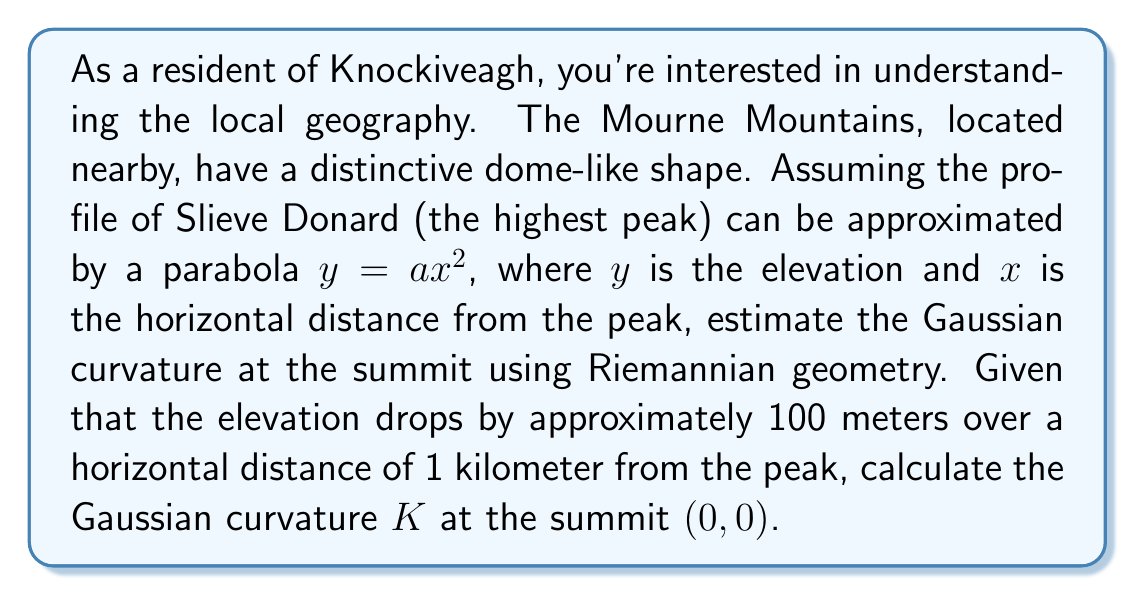Can you answer this question? To solve this problem, we'll follow these steps:

1) First, we need to determine the value of $a$ in the parabolic equation $y = ax^2$. Given that the elevation drops by 100 meters over 1 kilometer horizontally, we can write:

   $-100 = a(1000^2)$
   $a = -\frac{100}{1000000} = -10^{-4}$

   So our surface is described by $z = f(x,y) = -10^{-4}(x^2 + y^2)$

2) In Riemannian geometry, for a surface described by $z = f(x,y)$, the Gaussian curvature $K$ at a point $(x,y)$ is given by:

   $$K = \frac{f_{xx}f_{yy} - f_{xy}^2}{(1 + f_x^2 + f_y^2)^2}$$

   where subscripts denote partial derivatives.

3) Let's calculate these derivatives:
   
   $f_x = -2 \cdot 10^{-4}x$
   $f_y = -2 \cdot 10^{-4}y$
   $f_{xx} = -2 \cdot 10^{-4}$
   $f_{yy} = -2 \cdot 10^{-4}$
   $f_{xy} = 0$

4) At the summit $(0,0)$, $f_x = f_y = 0$, so our equation simplifies to:

   $$K = f_{xx}f_{yy} - f_{xy}^2$$

5) Substituting our values:

   $$K = (-2 \cdot 10^{-4})(-2 \cdot 10^{-4}) - 0^2 = 4 \cdot 10^{-8}$$

Therefore, the Gaussian curvature at the summit is $4 \cdot 10^{-8} \text{ m}^{-2}$.
Answer: $4 \cdot 10^{-8} \text{ m}^{-2}$ 